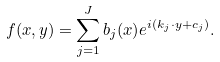Convert formula to latex. <formula><loc_0><loc_0><loc_500><loc_500>f ( x , y ) = \sum _ { j = 1 } ^ { J } b _ { j } ( x ) e ^ { i ( k _ { j } \cdot y + c _ { j } ) } .</formula> 